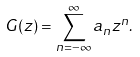Convert formula to latex. <formula><loc_0><loc_0><loc_500><loc_500>G ( z ) = \sum _ { n = - \infty } ^ { \infty } a _ { n } z ^ { n } .</formula> 